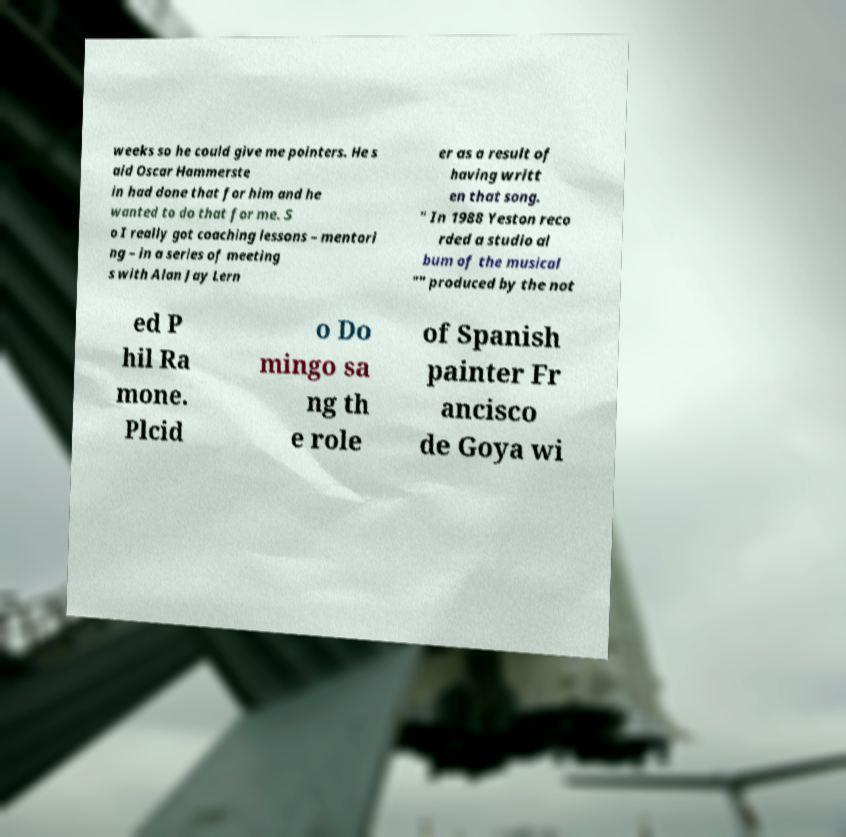There's text embedded in this image that I need extracted. Can you transcribe it verbatim? weeks so he could give me pointers. He s aid Oscar Hammerste in had done that for him and he wanted to do that for me. S o I really got coaching lessons – mentori ng – in a series of meeting s with Alan Jay Lern er as a result of having writt en that song. " In 1988 Yeston reco rded a studio al bum of the musical "" produced by the not ed P hil Ra mone. Plcid o Do mingo sa ng th e role of Spanish painter Fr ancisco de Goya wi 